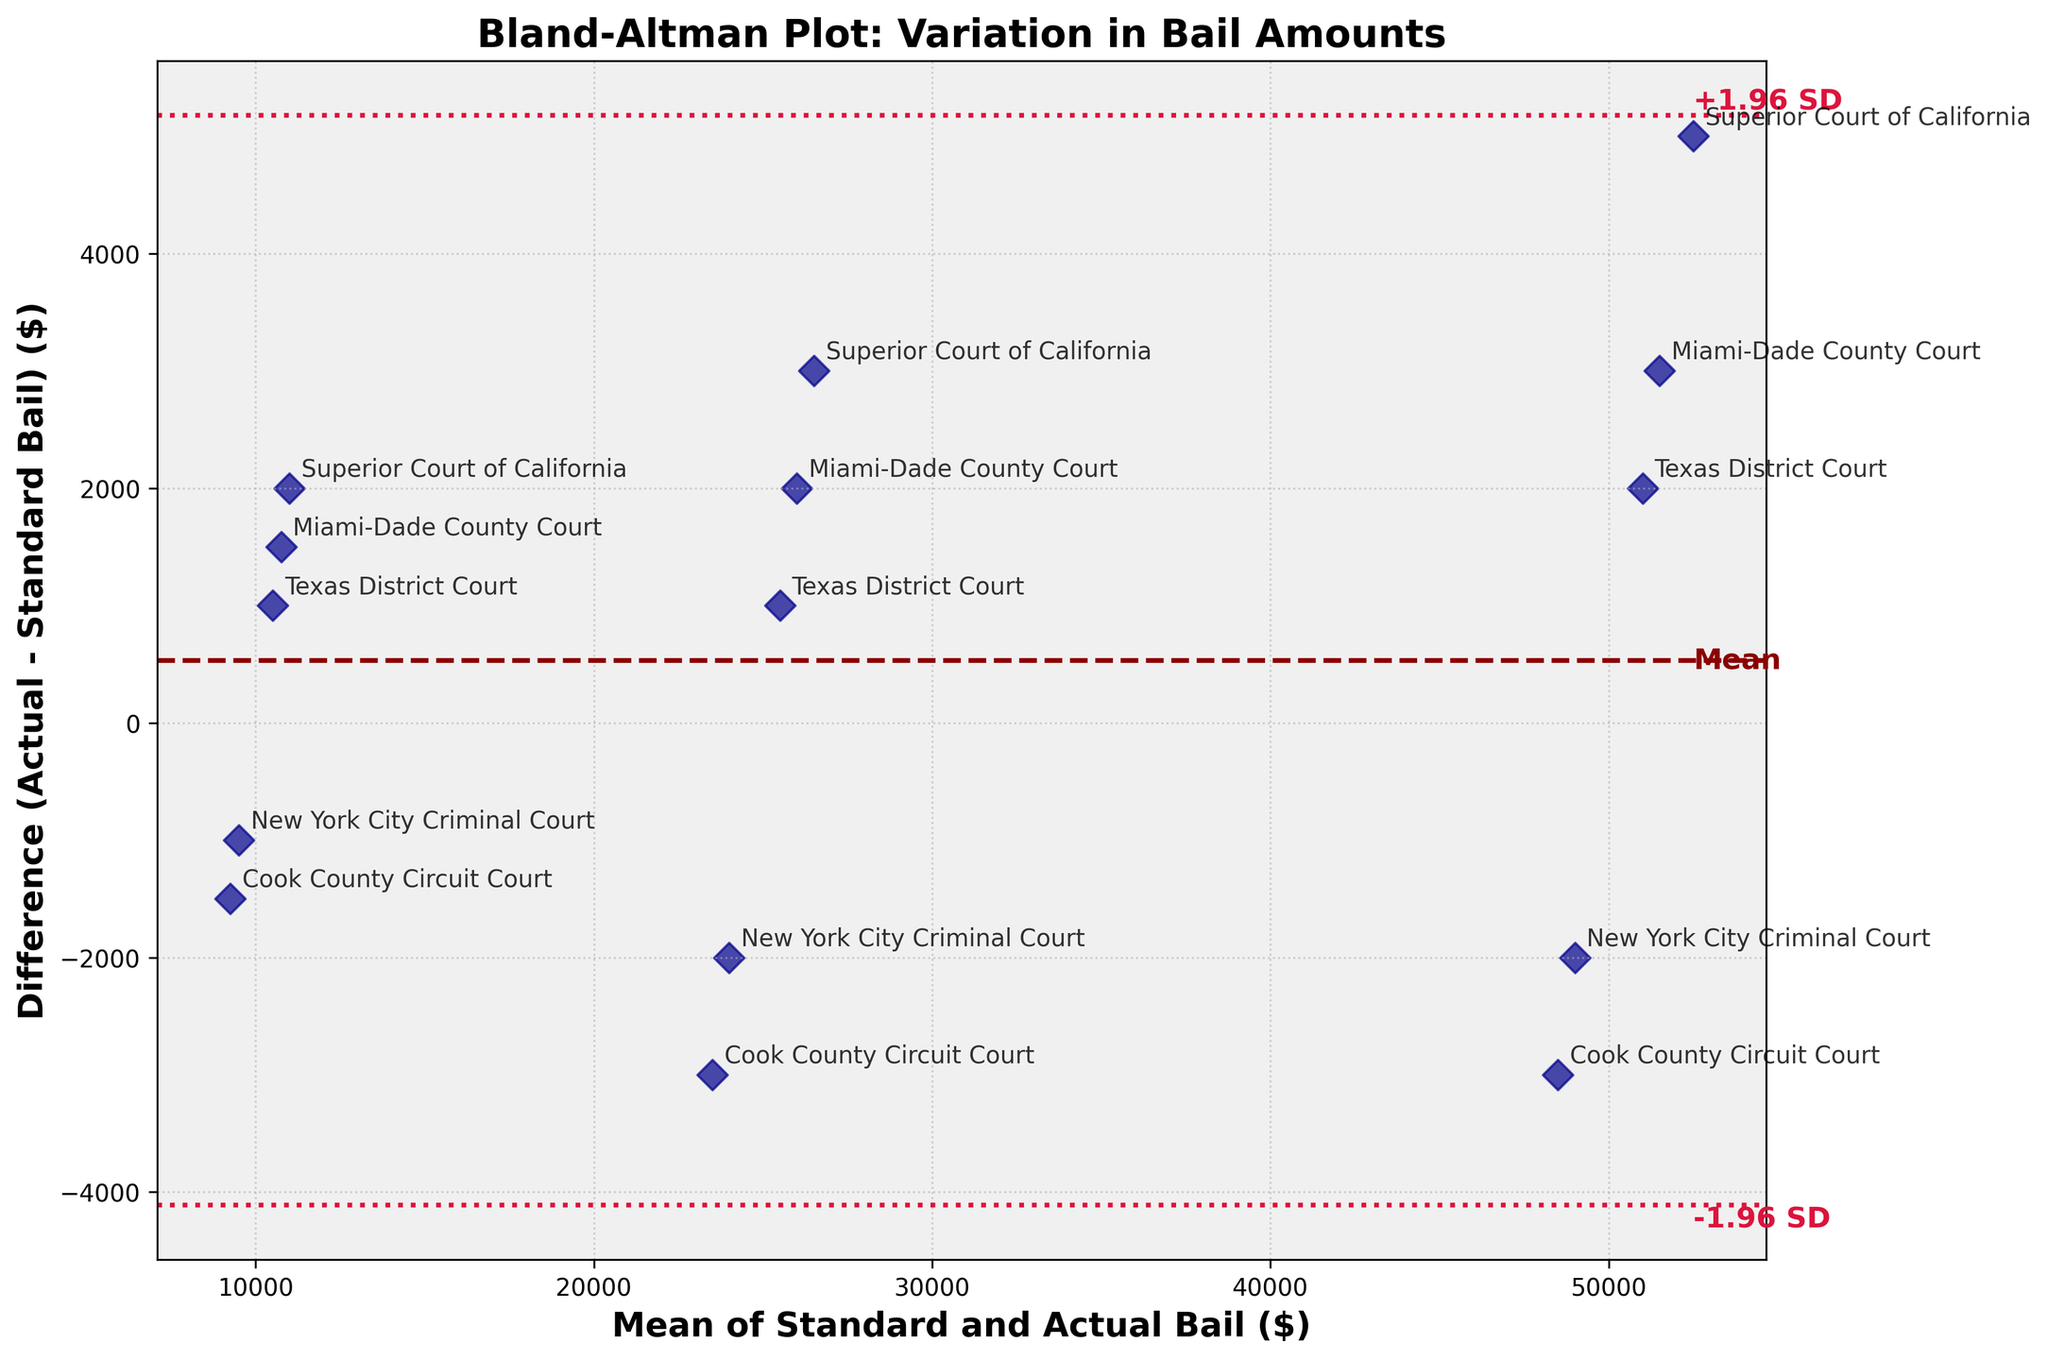How many data points are in the plot? Count the number of points visible in the scatter plot. You will see there are 15 data points, one for each court-offense pair.
Answer: 15 What is the title of the plot? Read the title at the top of the plot. It states "Bland-Altman Plot: Variation in Bail Amounts".
Answer: Bland-Altman Plot: Variation in Bail Amounts Which court has the greatest positive difference between actual and standard bail for aggravated assault? Locate the points labeled with court names for aggravated assault. The Superior Court of California has the highest positive difference at $5,000.
Answer: Superior Court of California What is the mean difference line value, and how is it visually represented? Observe the horizontal line running through the center of the plot. It is marked as "Mean" and is the mean difference between actual and standard bail amounts.
Answer: $0 How is the spread of differences quantified on the plot? Look at the dashed and dotted horizontal lines. They represent the mean difference (solid line) and ±1.96 standard deviations from the mean (dotted lines).
Answer: Mean and ±1.96 SD What is the range of the mean of standard and actual bail values in the plot? Check the x-axis for the minimum and maximum values of the average bail amounts. The values range from ~$10,000 to ~$52,500.
Answer: ~$10,000 to ~$52,500 Based on the plot, do most courts set actual bail amounts above or below the standard bail for drug possession? Inspect the points labeled with court names for drug possession. Most courts are below the mean difference line, indicating lower actual bail amounts.
Answer: Below Which offense shows the greatest variation in bail amounts across different courts? Compare the spread of points for each offense. Aggravated Assault has the widest spread in differences.
Answer: Aggravated Assault What does a positive difference indicate in the context of this plot? A positive difference means the actual bail amount set by a court is higher than the standard bail amount for a particular offense.
Answer: Actual bail > Standard bail Is the standard deviation consistent across all ranges of the mean bail amount? Look at the spacing of points relative to the ±1.96 SD lines. The variability seems consistent across all ranges of mean bail amounts.
Answer: Yes 